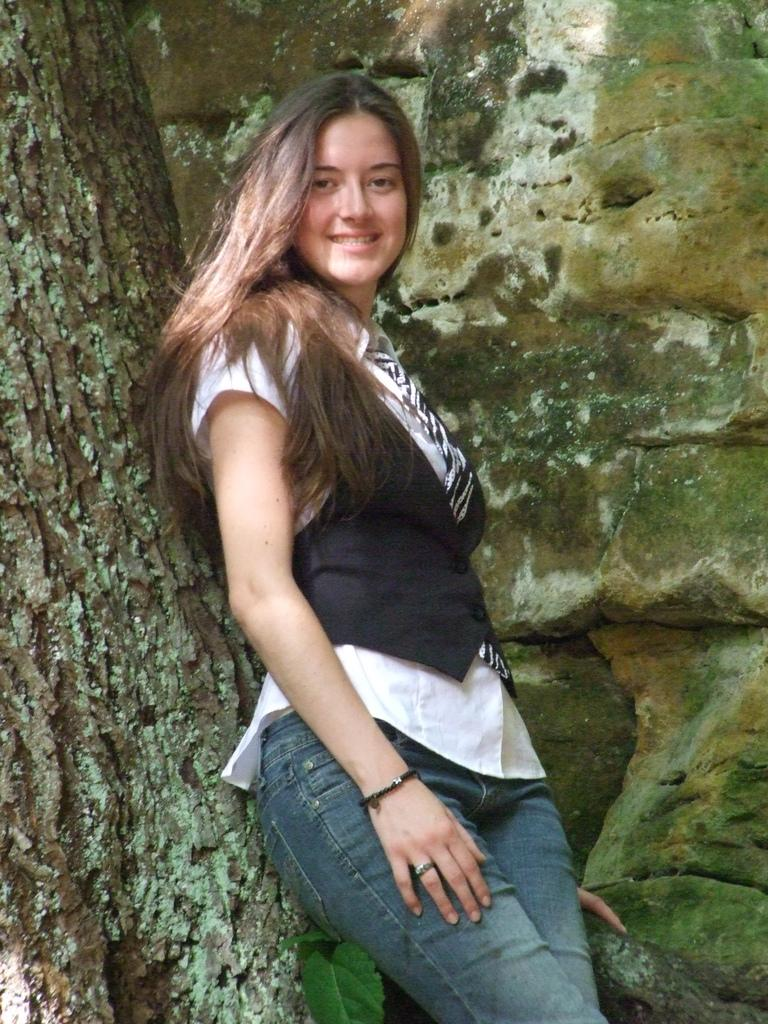Who is present in the image? There is a girl in the image. What is the girl doing in the image? The girl is standing in the image. How does the girl appear to be feeling in the image? The girl has a smile on her face, indicating that she is happy. What can be seen beside the girl in the image? There is a tree beside the girl. What is visible behind the girl in the image? There is a wall with rocks behind the girl. What type of wool is the girl using to knit in the image? There is no wool or knitting activity present in the image. How many arms does the girl have in the image? The girl has two arms in the image, as is typical for humans. 